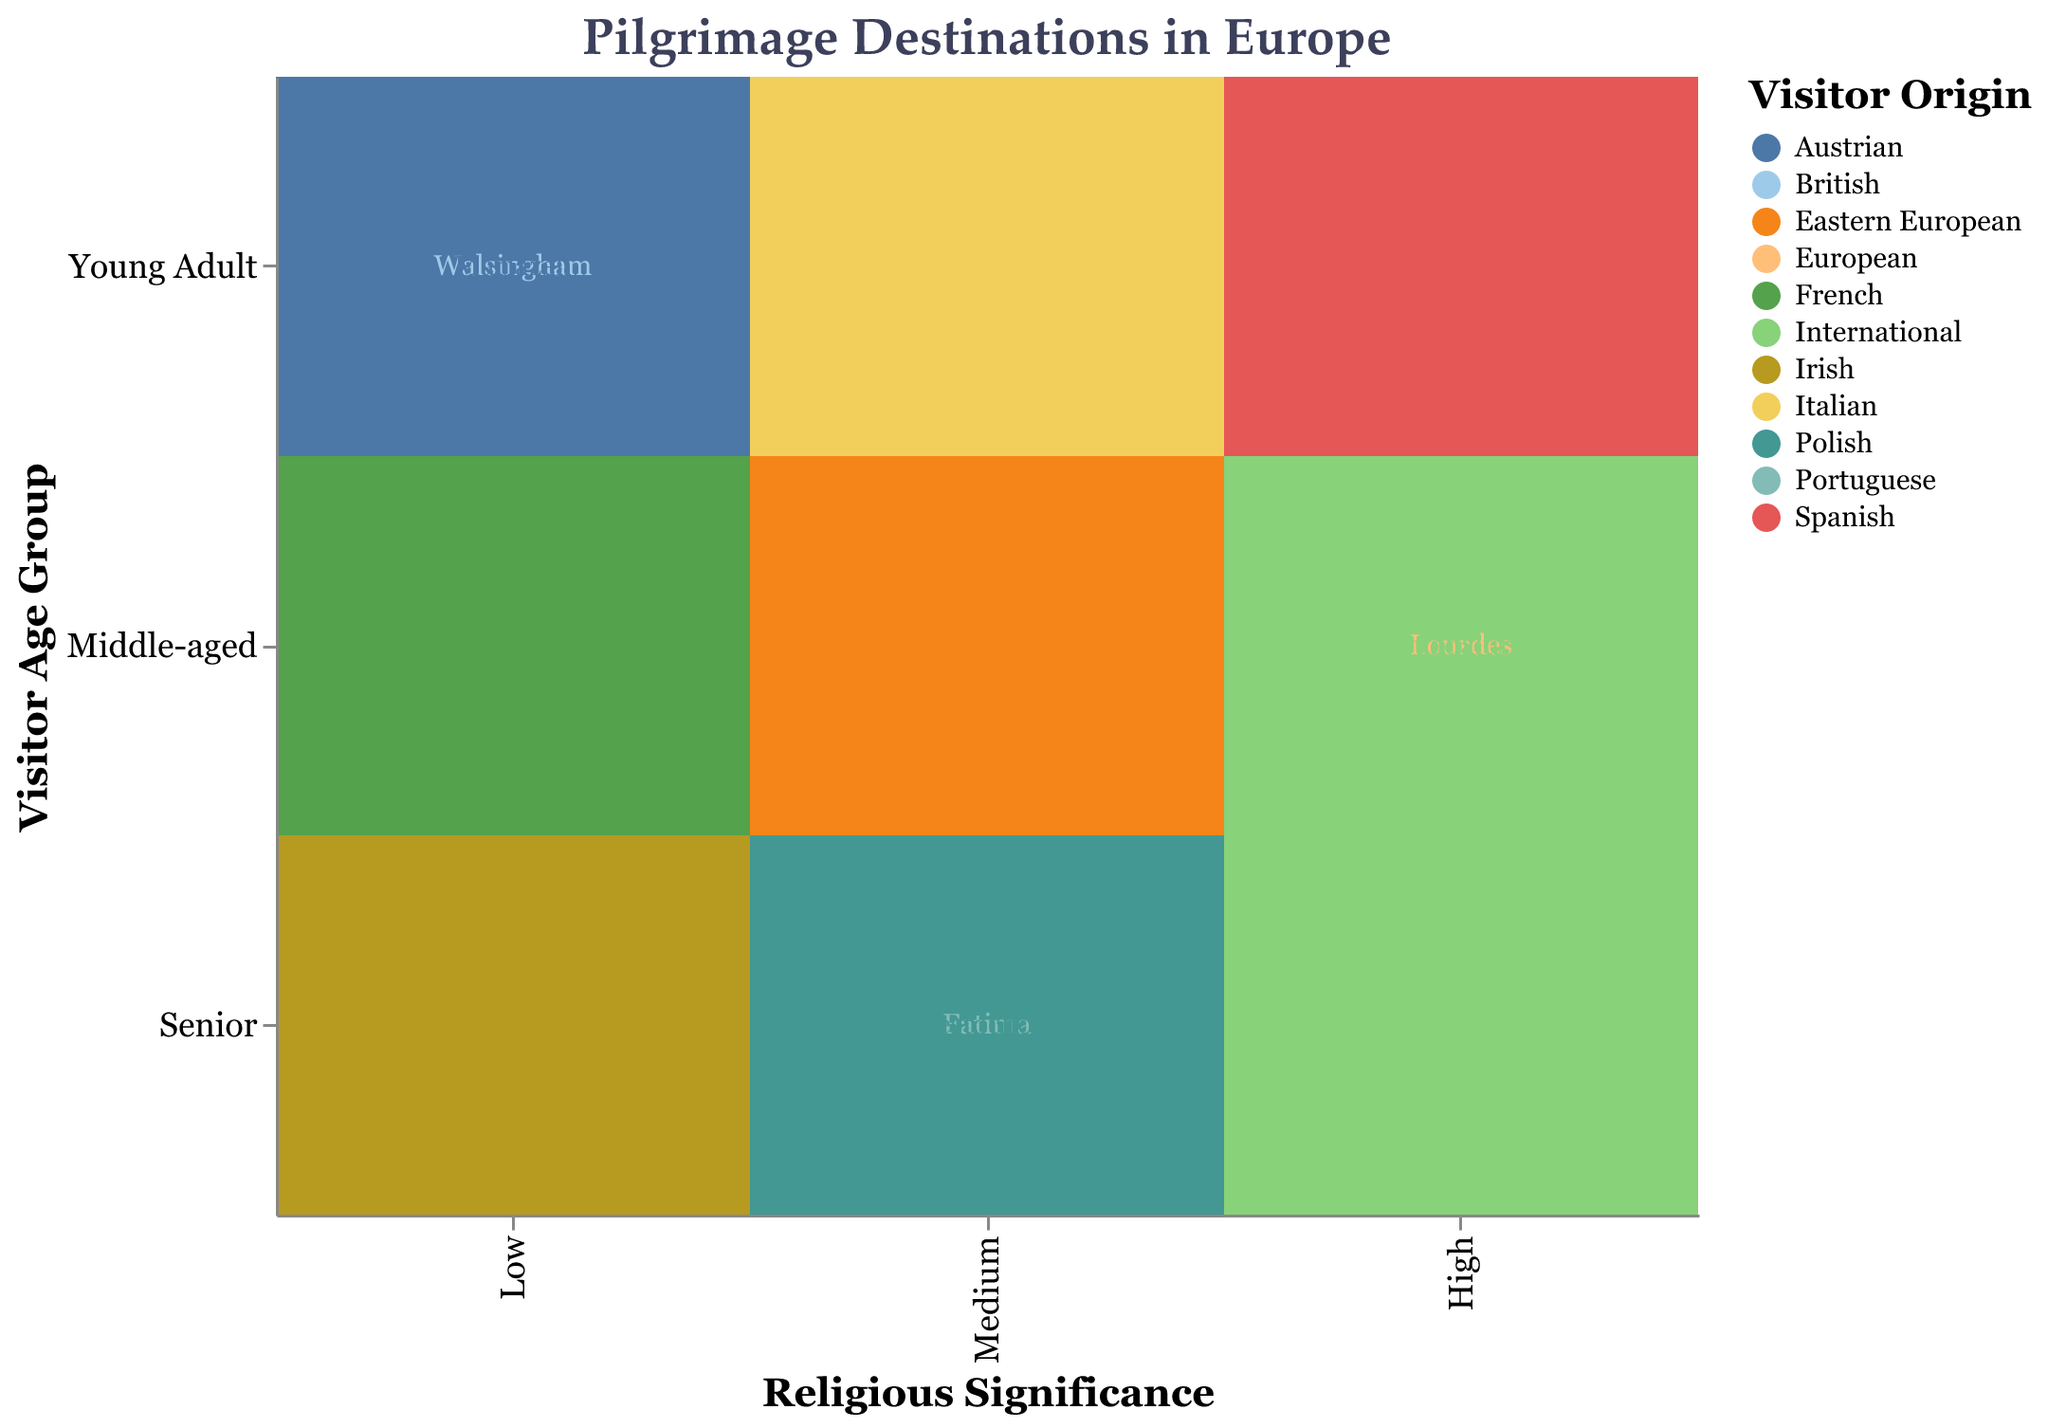What is the title of the mosaic plot? The title is usually located at the top and is prominently displayed.
Answer: Pilgrimage Destinations in Europe Which pilgrimage destination is associated with "High" religious significance and "Young Adult" visitor age group? Look for the intersection of "High" religious significance and "Young Adult" visitor age group, and see which destination is listed there.
Answer: Santiago de Compostela How many pilgrimage destinations have a "Medium" religious significance? Count the number of destination points that fall under the "Medium" religious significance category on the x-axis.
Answer: Four Which visitor origin appears most frequently in the plot? Identify the origin category that appears the most across different destinations and age groups by analyzing the color coding.
Answer: European What is the most common visitor age group for destinations with "Low" religious significance? Observe which age group (Senior, Middle-aged, Young Adult) appears most frequently in the "Low" category on the x-axis.
Answer: Young Adult Which destinations cater to international visitors? Look for destinations that are color-coded to represent "International" in the legend.
Answer: Vatican City, Guadalupe Compare the number of destinations that have "High" religious significance to those that have "Low" religious significance. Count the number of destinations in both the "High" and "Low" categories on the x-axis and compare.
Answer: 4 High, 4 Low What is the visitor origin for "Fatima" and what is its religious significance level? Locate "Fatima" on the plot and identify its color (visitor origin) and its position on the x-axis (religious significance level).
Answer: Portuguese, Medium How many destinations cater to middle-aged visitors? Count the number of destination points in the "Middle-aged" row across all significance levels.
Answer: Three What is the percentage of destinations with "Low" religious significance that attract young adults? Identify the number of destinations in the "Low" category that attract young adults and divide by the total number of destinations in the "Low" category, then multiply by 100.
Answer: 2/4 * 100 = 50% 